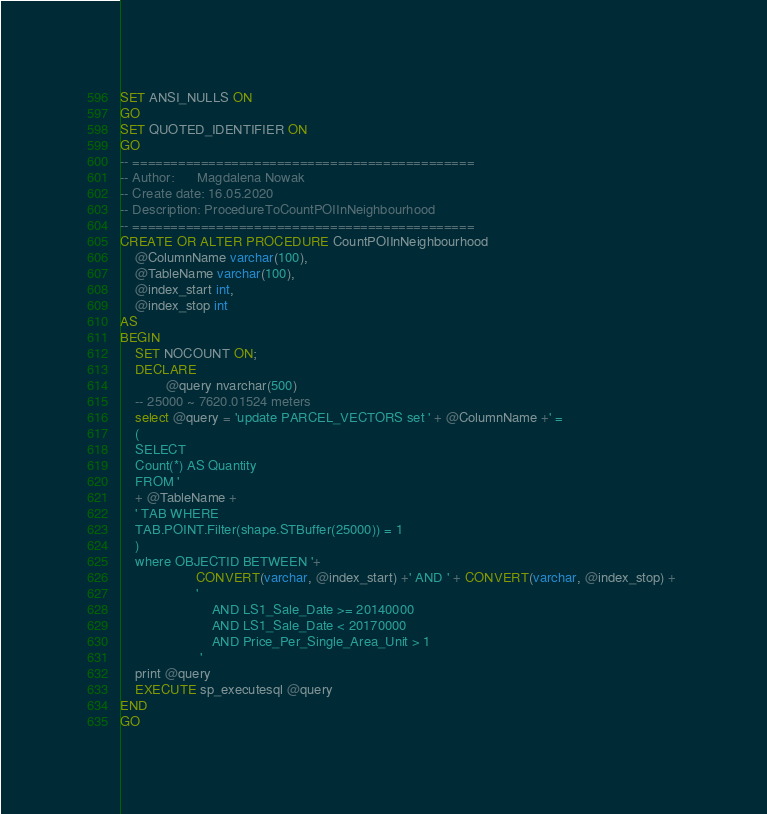Convert code to text. <code><loc_0><loc_0><loc_500><loc_500><_SQL_>
SET ANSI_NULLS ON
GO
SET QUOTED_IDENTIFIER ON
GO
-- =============================================
-- Author:		Magdalena Nowak
-- Create date: 16.05.2020
-- Description:	ProcedureToCountPOIInNeighbourhood
-- =============================================
CREATE OR ALTER PROCEDURE CountPOIInNeighbourhood
	@ColumnName varchar(100),
	@TableName varchar(100),
	@index_start int,
	@index_stop int
AS
BEGIN
	SET NOCOUNT ON;
	DECLARE
			@query nvarchar(500)
    -- 25000 ~ 7620.01524 meters
	select @query = 'update PARCEL_VECTORS set ' + @ColumnName +' = 
	(
	SELECT
	Count(*) AS Quantity
	FROM '
	+ @TableName +
	' TAB WHERE
	TAB.POINT.Filter(shape.STBuffer(25000)) = 1
	)
	where OBJECTID BETWEEN '+ 
					CONVERT(varchar, @index_start) +' AND ' + CONVERT(varchar, @index_stop) + 
					'
						AND LS1_Sale_Date >= 20140000
						AND LS1_Sale_Date < 20170000
						AND Price_Per_Single_Area_Unit > 1
					 '
	print @query
	EXECUTE sp_executesql @query
END
GO</code> 